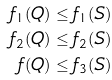<formula> <loc_0><loc_0><loc_500><loc_500>f _ { 1 } ( Q ) & \leq f _ { 1 } ( S ) \\ f _ { 2 } ( Q ) & \leq f _ { 2 } ( S ) \\ f ( Q ) & \leq f _ { 3 } ( S )</formula> 